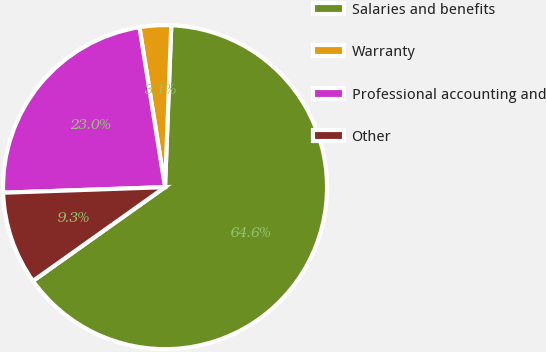Convert chart to OTSL. <chart><loc_0><loc_0><loc_500><loc_500><pie_chart><fcel>Salaries and benefits<fcel>Warranty<fcel>Professional accounting and<fcel>Other<nl><fcel>64.55%<fcel>3.14%<fcel>23.02%<fcel>9.28%<nl></chart> 